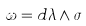Convert formula to latex. <formula><loc_0><loc_0><loc_500><loc_500>\omega = d \lambda \wedge \sigma</formula> 